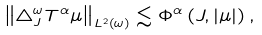<formula> <loc_0><loc_0><loc_500><loc_500>\left \| \bigtriangleup _ { J } ^ { \omega } T ^ { \alpha } \mu \right \| _ { L ^ { 2 } \left ( \omega \right ) } \lesssim \Phi ^ { \alpha } \left ( J , \left | \mu \right | \right ) ,</formula> 